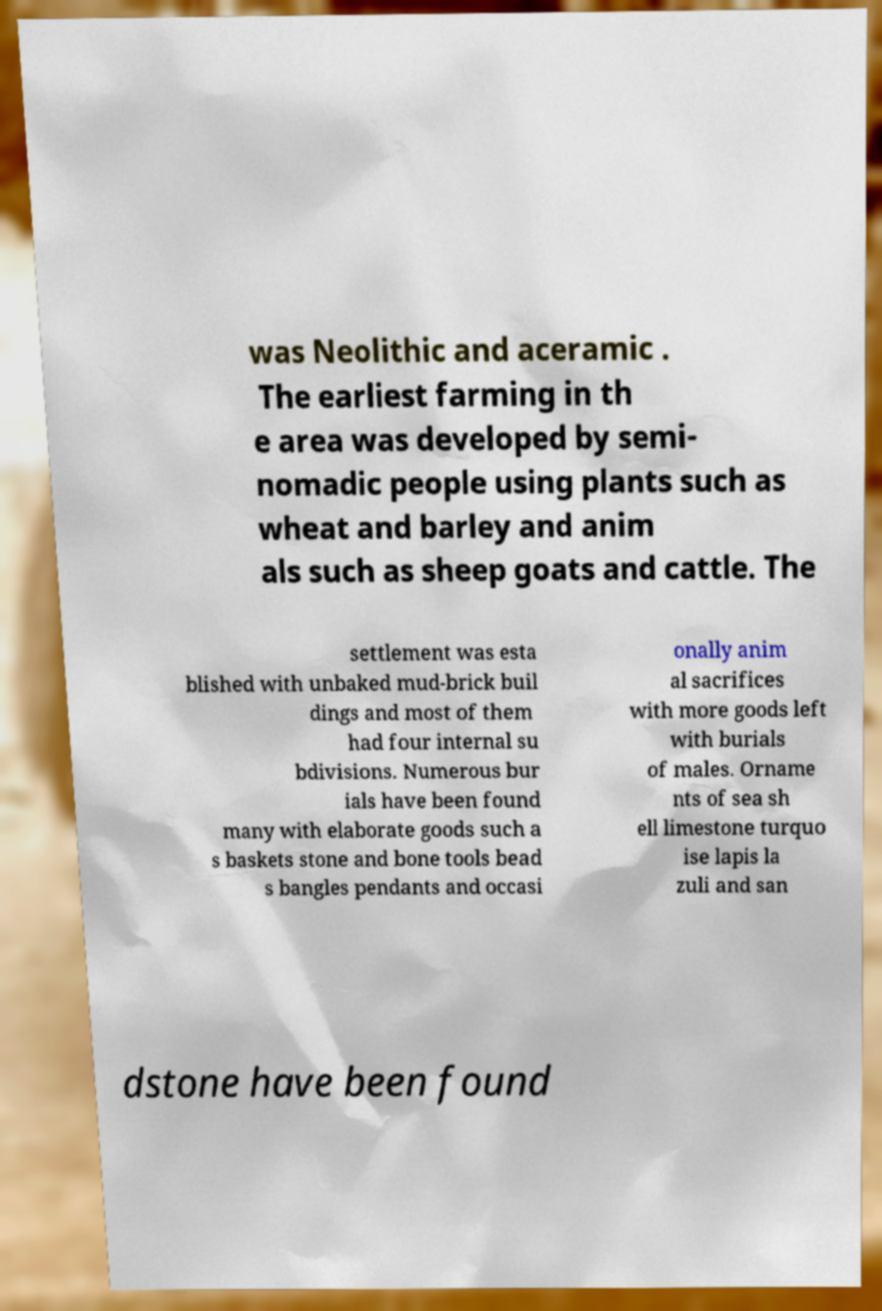What messages or text are displayed in this image? I need them in a readable, typed format. was Neolithic and aceramic . The earliest farming in th e area was developed by semi- nomadic people using plants such as wheat and barley and anim als such as sheep goats and cattle. The settlement was esta blished with unbaked mud-brick buil dings and most of them had four internal su bdivisions. Numerous bur ials have been found many with elaborate goods such a s baskets stone and bone tools bead s bangles pendants and occasi onally anim al sacrifices with more goods left with burials of males. Orname nts of sea sh ell limestone turquo ise lapis la zuli and san dstone have been found 